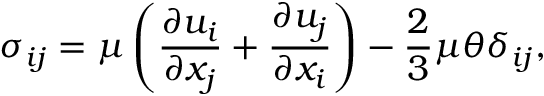<formula> <loc_0><loc_0><loc_500><loc_500>\sigma _ { i j } = \mu \left ( \frac { \partial u _ { i } } { \partial x _ { j } } + \frac { \partial u _ { j } } { \partial x _ { i } } \right ) - \frac { 2 } { 3 } \mu \theta \delta _ { i j } ,</formula> 